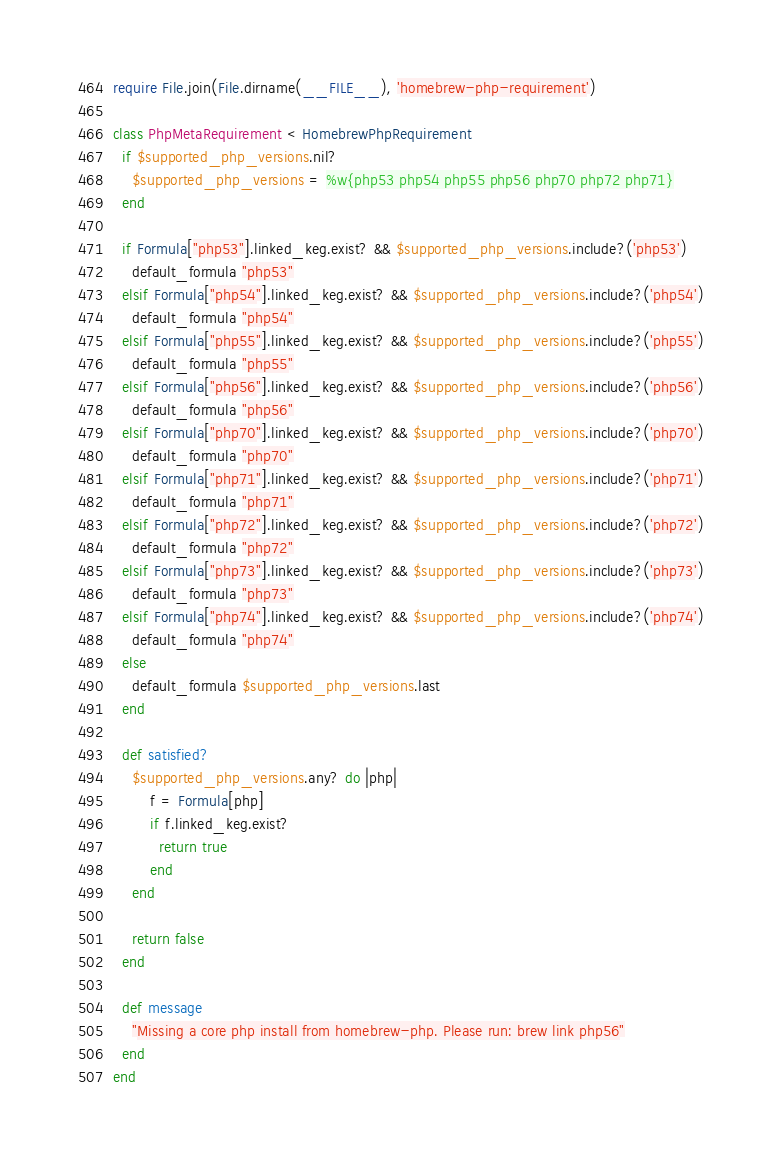Convert code to text. <code><loc_0><loc_0><loc_500><loc_500><_Ruby_>require File.join(File.dirname(__FILE__), 'homebrew-php-requirement')

class PhpMetaRequirement < HomebrewPhpRequirement
  if $supported_php_versions.nil?
    $supported_php_versions = %w{php53 php54 php55 php56 php70 php72 php71}
  end

  if Formula["php53"].linked_keg.exist? && $supported_php_versions.include?('php53')
    default_formula "php53"
  elsif Formula["php54"].linked_keg.exist? && $supported_php_versions.include?('php54')
    default_formula "php54"
  elsif Formula["php55"].linked_keg.exist? && $supported_php_versions.include?('php55')
    default_formula "php55"
  elsif Formula["php56"].linked_keg.exist? && $supported_php_versions.include?('php56')
    default_formula "php56"
  elsif Formula["php70"].linked_keg.exist? && $supported_php_versions.include?('php70')
    default_formula "php70"
  elsif Formula["php71"].linked_keg.exist? && $supported_php_versions.include?('php71')
    default_formula "php71"
  elsif Formula["php72"].linked_keg.exist? && $supported_php_versions.include?('php72')
    default_formula "php72"
  elsif Formula["php73"].linked_keg.exist? && $supported_php_versions.include?('php73')
    default_formula "php73"
  elsif Formula["php74"].linked_keg.exist? && $supported_php_versions.include?('php74')
    default_formula "php74"
  else
    default_formula $supported_php_versions.last
  end

  def satisfied?
    $supported_php_versions.any? do |php|
        f = Formula[php]
        if f.linked_keg.exist?
          return true
        end
    end

    return false
  end

  def message
    "Missing a core php install from homebrew-php. Please run: brew link php56"
  end
end
</code> 